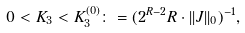<formula> <loc_0><loc_0><loc_500><loc_500>0 < K _ { 3 } < K _ { 3 } ^ { ( 0 ) } \colon = ( 2 ^ { R - 2 } R \cdot | | J | | _ { 0 } ) ^ { - 1 } ,</formula> 